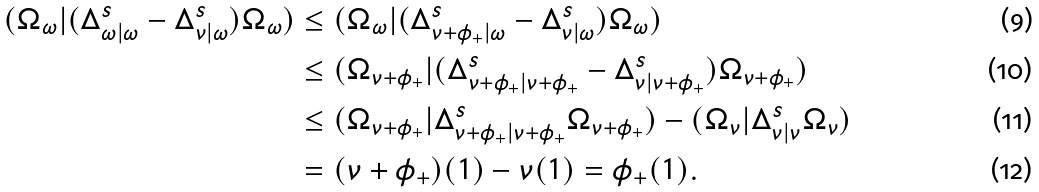<formula> <loc_0><loc_0><loc_500><loc_500>( \Omega _ { \omega } | ( \Delta _ { \omega | \omega } ^ { s } - \Delta _ { \nu | \omega } ^ { s } ) \Omega _ { \omega } ) & \leq ( \Omega _ { \omega } | ( \Delta _ { \nu + \phi _ { + } | \omega } ^ { s } - \Delta _ { \nu | \omega } ^ { s } ) \Omega _ { \omega } ) \\ & \leq ( \Omega _ { \nu + \phi _ { + } } | ( \Delta _ { \nu + \phi _ { + } | \nu + \phi _ { + } } ^ { s } - \Delta _ { \nu | \nu + \phi _ { + } } ^ { s } ) \Omega _ { \nu + \phi _ { + } } ) \\ & \leq ( \Omega _ { \nu + \phi _ { + } } | \Delta _ { \nu + \phi _ { + } | \nu + \phi _ { + } } ^ { s } \Omega _ { \nu + \phi _ { + } } ) - ( \Omega _ { \nu } | \Delta _ { \nu | \nu } ^ { s } \Omega _ { \nu } ) \\ & = ( \nu + \phi _ { + } ) ( 1 ) - \nu ( 1 ) = \phi _ { + } ( 1 ) .</formula> 